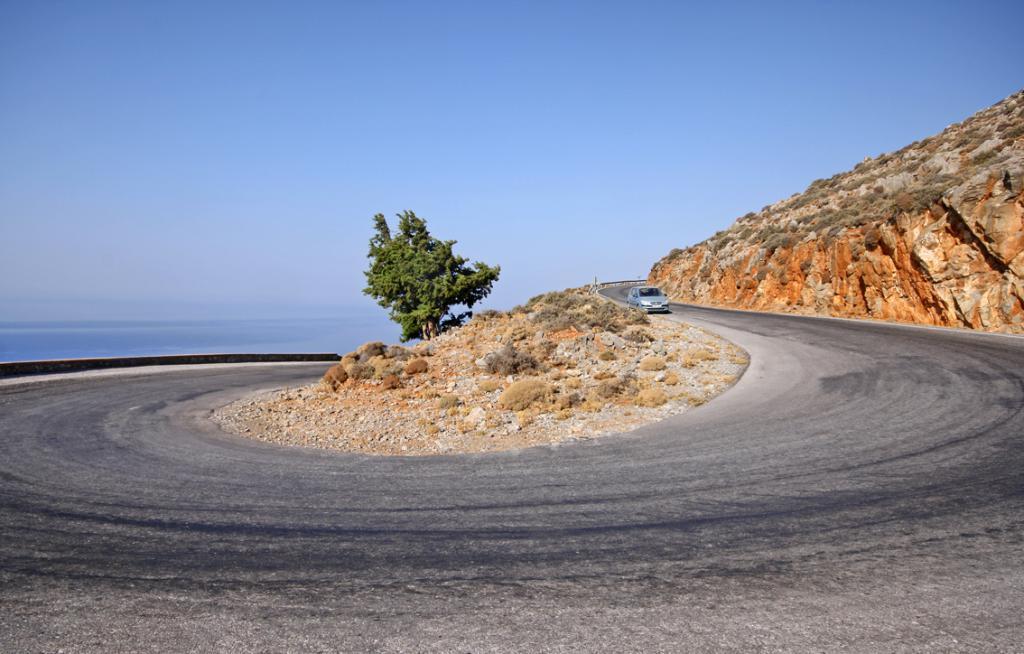Describe this image in one or two sentences. In this image we can see a car on the road. We can also see some stones, a tree, some plants, the hill and the sky which looks cloudy. 